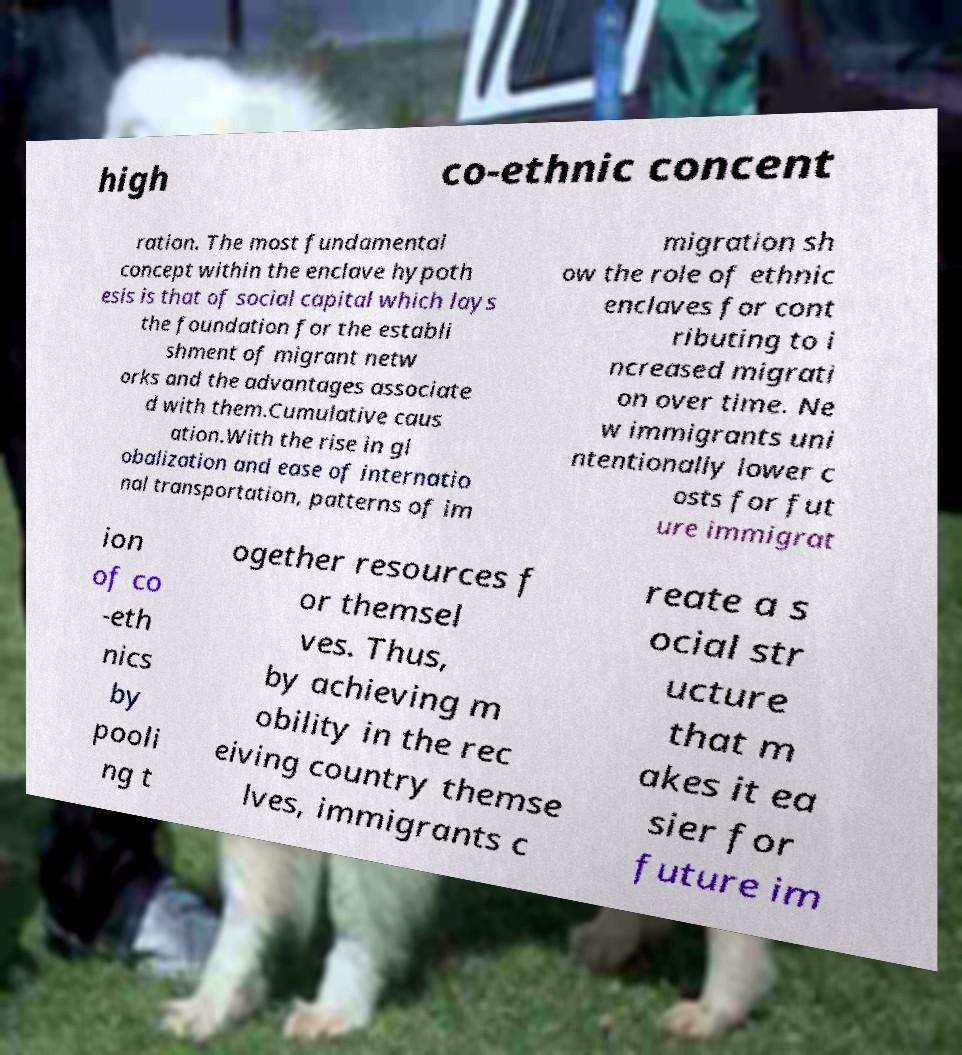Could you extract and type out the text from this image? high co-ethnic concent ration. The most fundamental concept within the enclave hypoth esis is that of social capital which lays the foundation for the establi shment of migrant netw orks and the advantages associate d with them.Cumulative caus ation.With the rise in gl obalization and ease of internatio nal transportation, patterns of im migration sh ow the role of ethnic enclaves for cont ributing to i ncreased migrati on over time. Ne w immigrants uni ntentionally lower c osts for fut ure immigrat ion of co -eth nics by pooli ng t ogether resources f or themsel ves. Thus, by achieving m obility in the rec eiving country themse lves, immigrants c reate a s ocial str ucture that m akes it ea sier for future im 